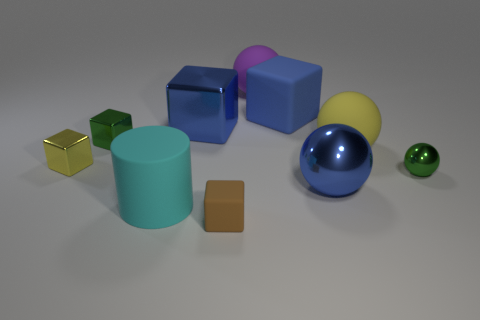There is a blue matte thing; is it the same shape as the tiny object in front of the cyan matte cylinder?
Your response must be concise. Yes. What is the shape of the rubber thing that is the same color as the big shiny cube?
Your answer should be very brief. Cube. Are there any red balls that have the same material as the yellow sphere?
Provide a short and direct response. No. Are there any other things that are made of the same material as the large cylinder?
Offer a terse response. Yes. The green object on the right side of the cube that is in front of the tiny green sphere is made of what material?
Ensure brevity in your answer.  Metal. What size is the rubber cube behind the blue metallic object in front of the blue metallic object left of the purple object?
Offer a very short reply. Large. What number of other objects are the same shape as the brown object?
Give a very brief answer. 4. There is a object that is in front of the cyan object; is its color the same as the big shiny object behind the green ball?
Your answer should be very brief. No. The metallic sphere that is the same size as the cylinder is what color?
Provide a short and direct response. Blue. Is there a big shiny thing of the same color as the cylinder?
Offer a very short reply. No. 